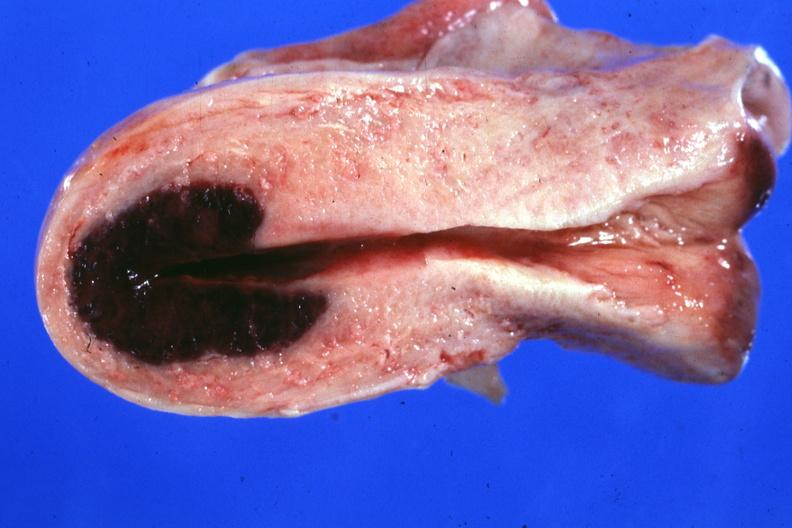what is present?
Answer the question using a single word or phrase. Female reproductive 